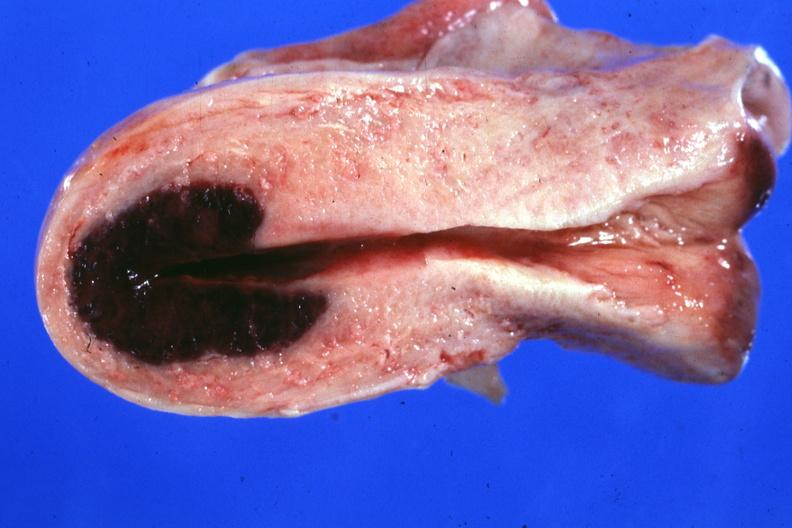what is present?
Answer the question using a single word or phrase. Female reproductive 